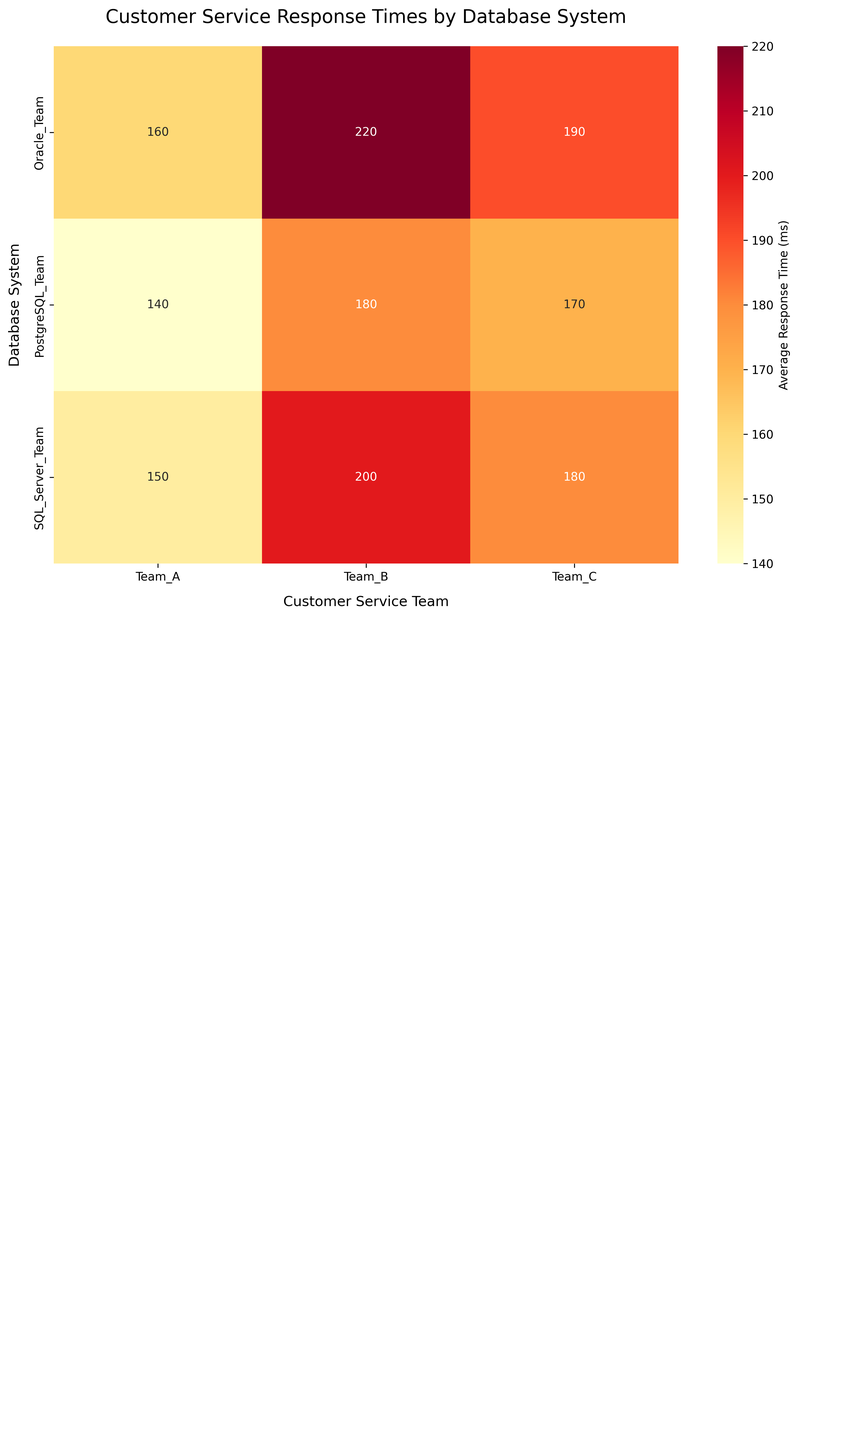What is the title of the figure? The title of the figure is usually located at the top of the chart and provides a summary of the chart contents. Here, it states what the chart is demonstrating.
Answer: Customer Service Response Times by Database System Which database system has the lowest average response time? To find the database system with the lowest average response time, look for the smallest number across all cells in the heatmap.
Answer: PostgreSQL_Team What is the range of response times for Team A? You need to consider the response times for Team A across all database systems and calculate the difference between the highest and lowest values. The values are 150 ms (SQL Server), 160 ms (Oracle), and 140 ms (PostgreSQL).
Answer: 20 ms Which customer service team has the highest average response time on SQL Server? Look at the SQL Server row and identify the highest value among Team A, Team B, and Team C.
Answer: Team B How does the average response time of Team B on Oracle compare to that on PostgreSQL? Compare the response times for Team B between Oracle (220 ms) and PostgreSQL (180 ms).
Answer: Oracle's Team B has 40 ms higher response time than PostgreSQL's Team B Which combination of database system and customer service team exhibits the highest efficiency percentage? While not directly shown in the heatmap, the text annotations next to each database system indicate the efficiency percentages. Identify the highest among them. PostgreSQL (96%), SQL Server (95%), and Oracle (94%).
Answer: PostgreSQL_Team If we average the response times for Team C across all database systems, what value do we get? Add the response times for Team C from each database system, then divide by the number of database systems: (180 + 190 + 170) / 3 = 180 ms.
Answer: 180 ms 